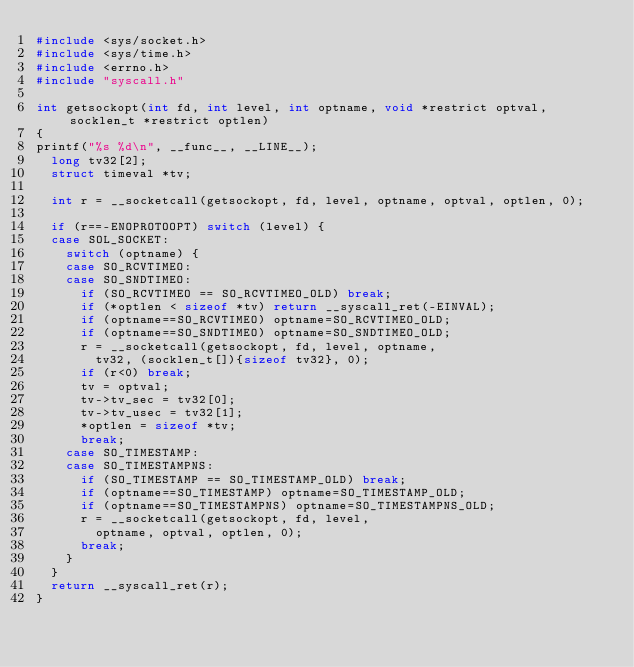Convert code to text. <code><loc_0><loc_0><loc_500><loc_500><_C_>#include <sys/socket.h>
#include <sys/time.h>
#include <errno.h>
#include "syscall.h"

int getsockopt(int fd, int level, int optname, void *restrict optval, socklen_t *restrict optlen)
{
printf("%s %d\n", __func__, __LINE__);
	long tv32[2];
	struct timeval *tv;

	int r = __socketcall(getsockopt, fd, level, optname, optval, optlen, 0);

	if (r==-ENOPROTOOPT) switch (level) {
	case SOL_SOCKET:
		switch (optname) {
		case SO_RCVTIMEO:
		case SO_SNDTIMEO:
			if (SO_RCVTIMEO == SO_RCVTIMEO_OLD) break;
			if (*optlen < sizeof *tv) return __syscall_ret(-EINVAL);
			if (optname==SO_RCVTIMEO) optname=SO_RCVTIMEO_OLD;
			if (optname==SO_SNDTIMEO) optname=SO_SNDTIMEO_OLD;
			r = __socketcall(getsockopt, fd, level, optname,
				tv32, (socklen_t[]){sizeof tv32}, 0);
			if (r<0) break;
			tv = optval;
			tv->tv_sec = tv32[0];
			tv->tv_usec = tv32[1];
			*optlen = sizeof *tv;
			break;
		case SO_TIMESTAMP:
		case SO_TIMESTAMPNS:
			if (SO_TIMESTAMP == SO_TIMESTAMP_OLD) break;
			if (optname==SO_TIMESTAMP) optname=SO_TIMESTAMP_OLD;
			if (optname==SO_TIMESTAMPNS) optname=SO_TIMESTAMPNS_OLD;
			r = __socketcall(getsockopt, fd, level,
				optname, optval, optlen, 0);
			break;
		}
	}
	return __syscall_ret(r);
}
</code> 